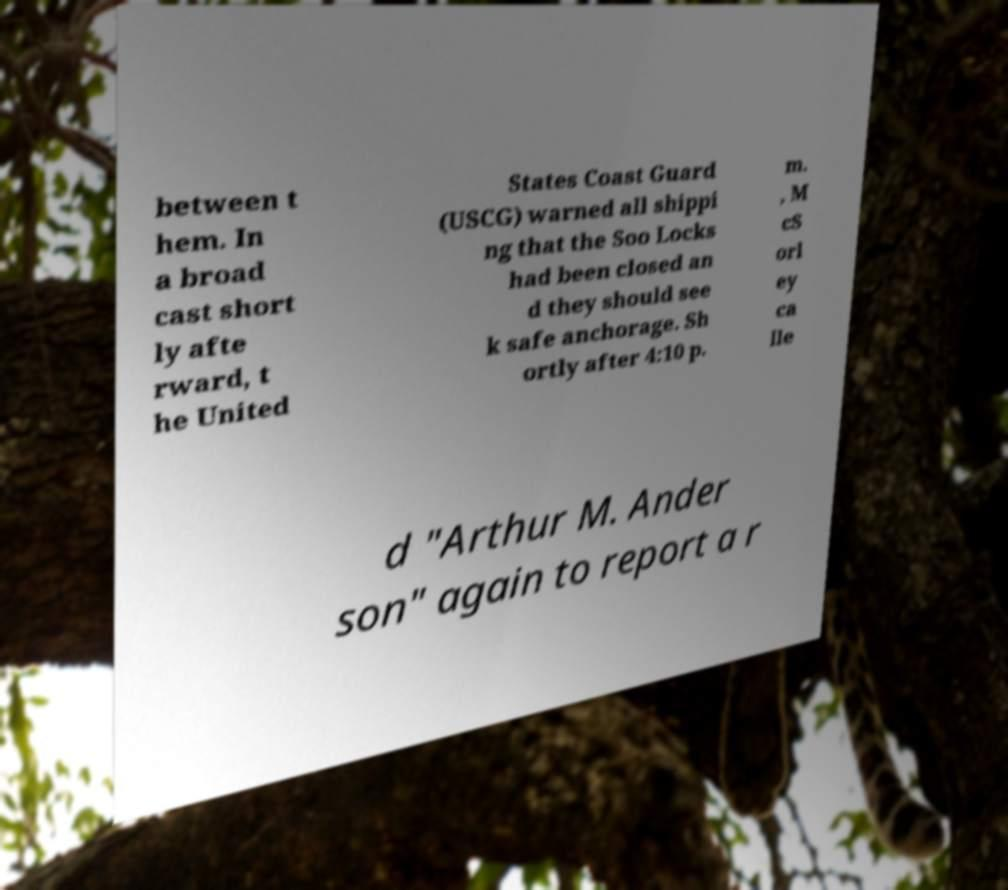There's text embedded in this image that I need extracted. Can you transcribe it verbatim? between t hem. In a broad cast short ly afte rward, t he United States Coast Guard (USCG) warned all shippi ng that the Soo Locks had been closed an d they should see k safe anchorage. Sh ortly after 4:10 p. m. , M cS orl ey ca lle d "Arthur M. Ander son" again to report a r 